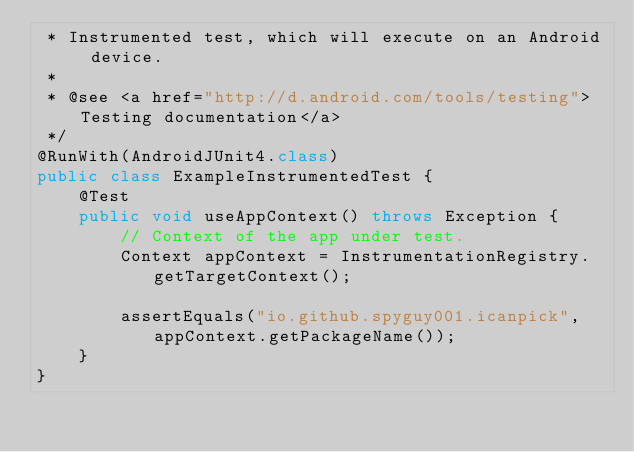Convert code to text. <code><loc_0><loc_0><loc_500><loc_500><_Java_> * Instrumented test, which will execute on an Android device.
 *
 * @see <a href="http://d.android.com/tools/testing">Testing documentation</a>
 */
@RunWith(AndroidJUnit4.class)
public class ExampleInstrumentedTest {
    @Test
    public void useAppContext() throws Exception {
        // Context of the app under test.
        Context appContext = InstrumentationRegistry.getTargetContext();

        assertEquals("io.github.spyguy001.icanpick", appContext.getPackageName());
    }
}
</code> 